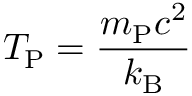<formula> <loc_0><loc_0><loc_500><loc_500>T _ { P } = { \frac { m _ { P } c ^ { 2 } } { k _ { B } } }</formula> 